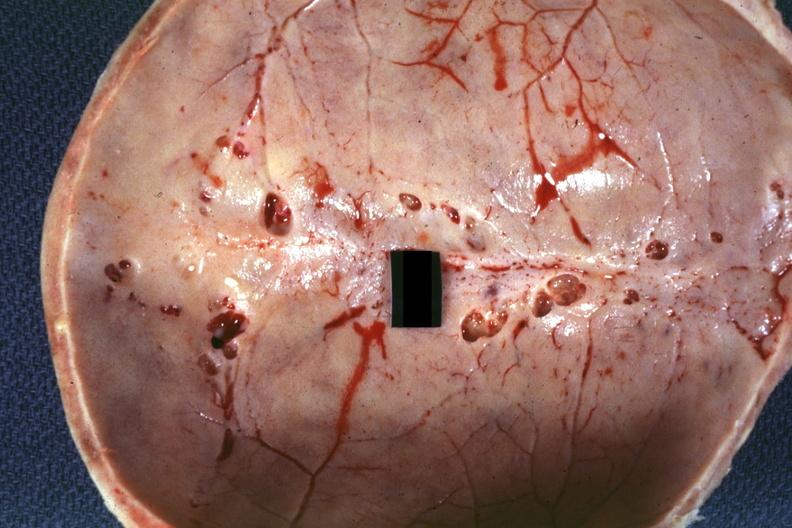does aorta show inner table view multiple venous lakes?
Answer the question using a single word or phrase. No 